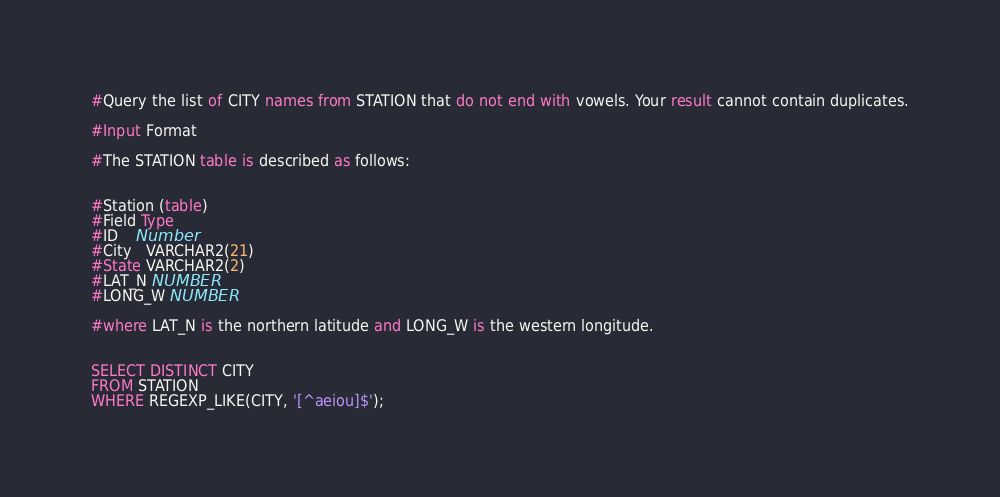<code> <loc_0><loc_0><loc_500><loc_500><_SQL_>#Query the list of CITY names from STATION that do not end with vowels. Your result cannot contain duplicates.

#Input Format

#The STATION table is described as follows:


#Station (table)
#Field Type
#ID    Number
#City   VARCHAR2(21)
#State VARCHAR2(2)
#LAT_N NUMBER
#LONG_W NUMBER

#where LAT_N is the northern latitude and LONG_W is the western longitude.


SELECT DISTINCT CITY
FROM STATION
WHERE REGEXP_LIKE(CITY, '[^aeiou]$');
</code> 